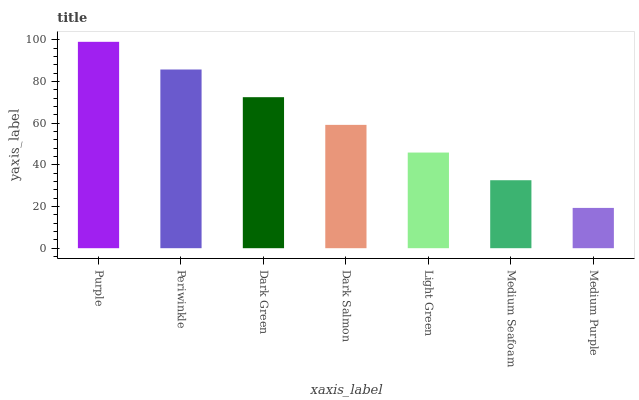Is Medium Purple the minimum?
Answer yes or no. Yes. Is Purple the maximum?
Answer yes or no. Yes. Is Periwinkle the minimum?
Answer yes or no. No. Is Periwinkle the maximum?
Answer yes or no. No. Is Purple greater than Periwinkle?
Answer yes or no. Yes. Is Periwinkle less than Purple?
Answer yes or no. Yes. Is Periwinkle greater than Purple?
Answer yes or no. No. Is Purple less than Periwinkle?
Answer yes or no. No. Is Dark Salmon the high median?
Answer yes or no. Yes. Is Dark Salmon the low median?
Answer yes or no. Yes. Is Periwinkle the high median?
Answer yes or no. No. Is Light Green the low median?
Answer yes or no. No. 